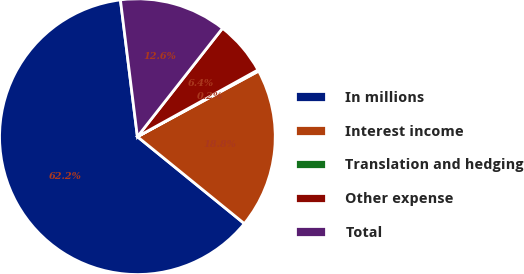<chart> <loc_0><loc_0><loc_500><loc_500><pie_chart><fcel>In millions<fcel>Interest income<fcel>Translation and hedging<fcel>Other expense<fcel>Total<nl><fcel>62.17%<fcel>18.76%<fcel>0.15%<fcel>6.36%<fcel>12.56%<nl></chart> 